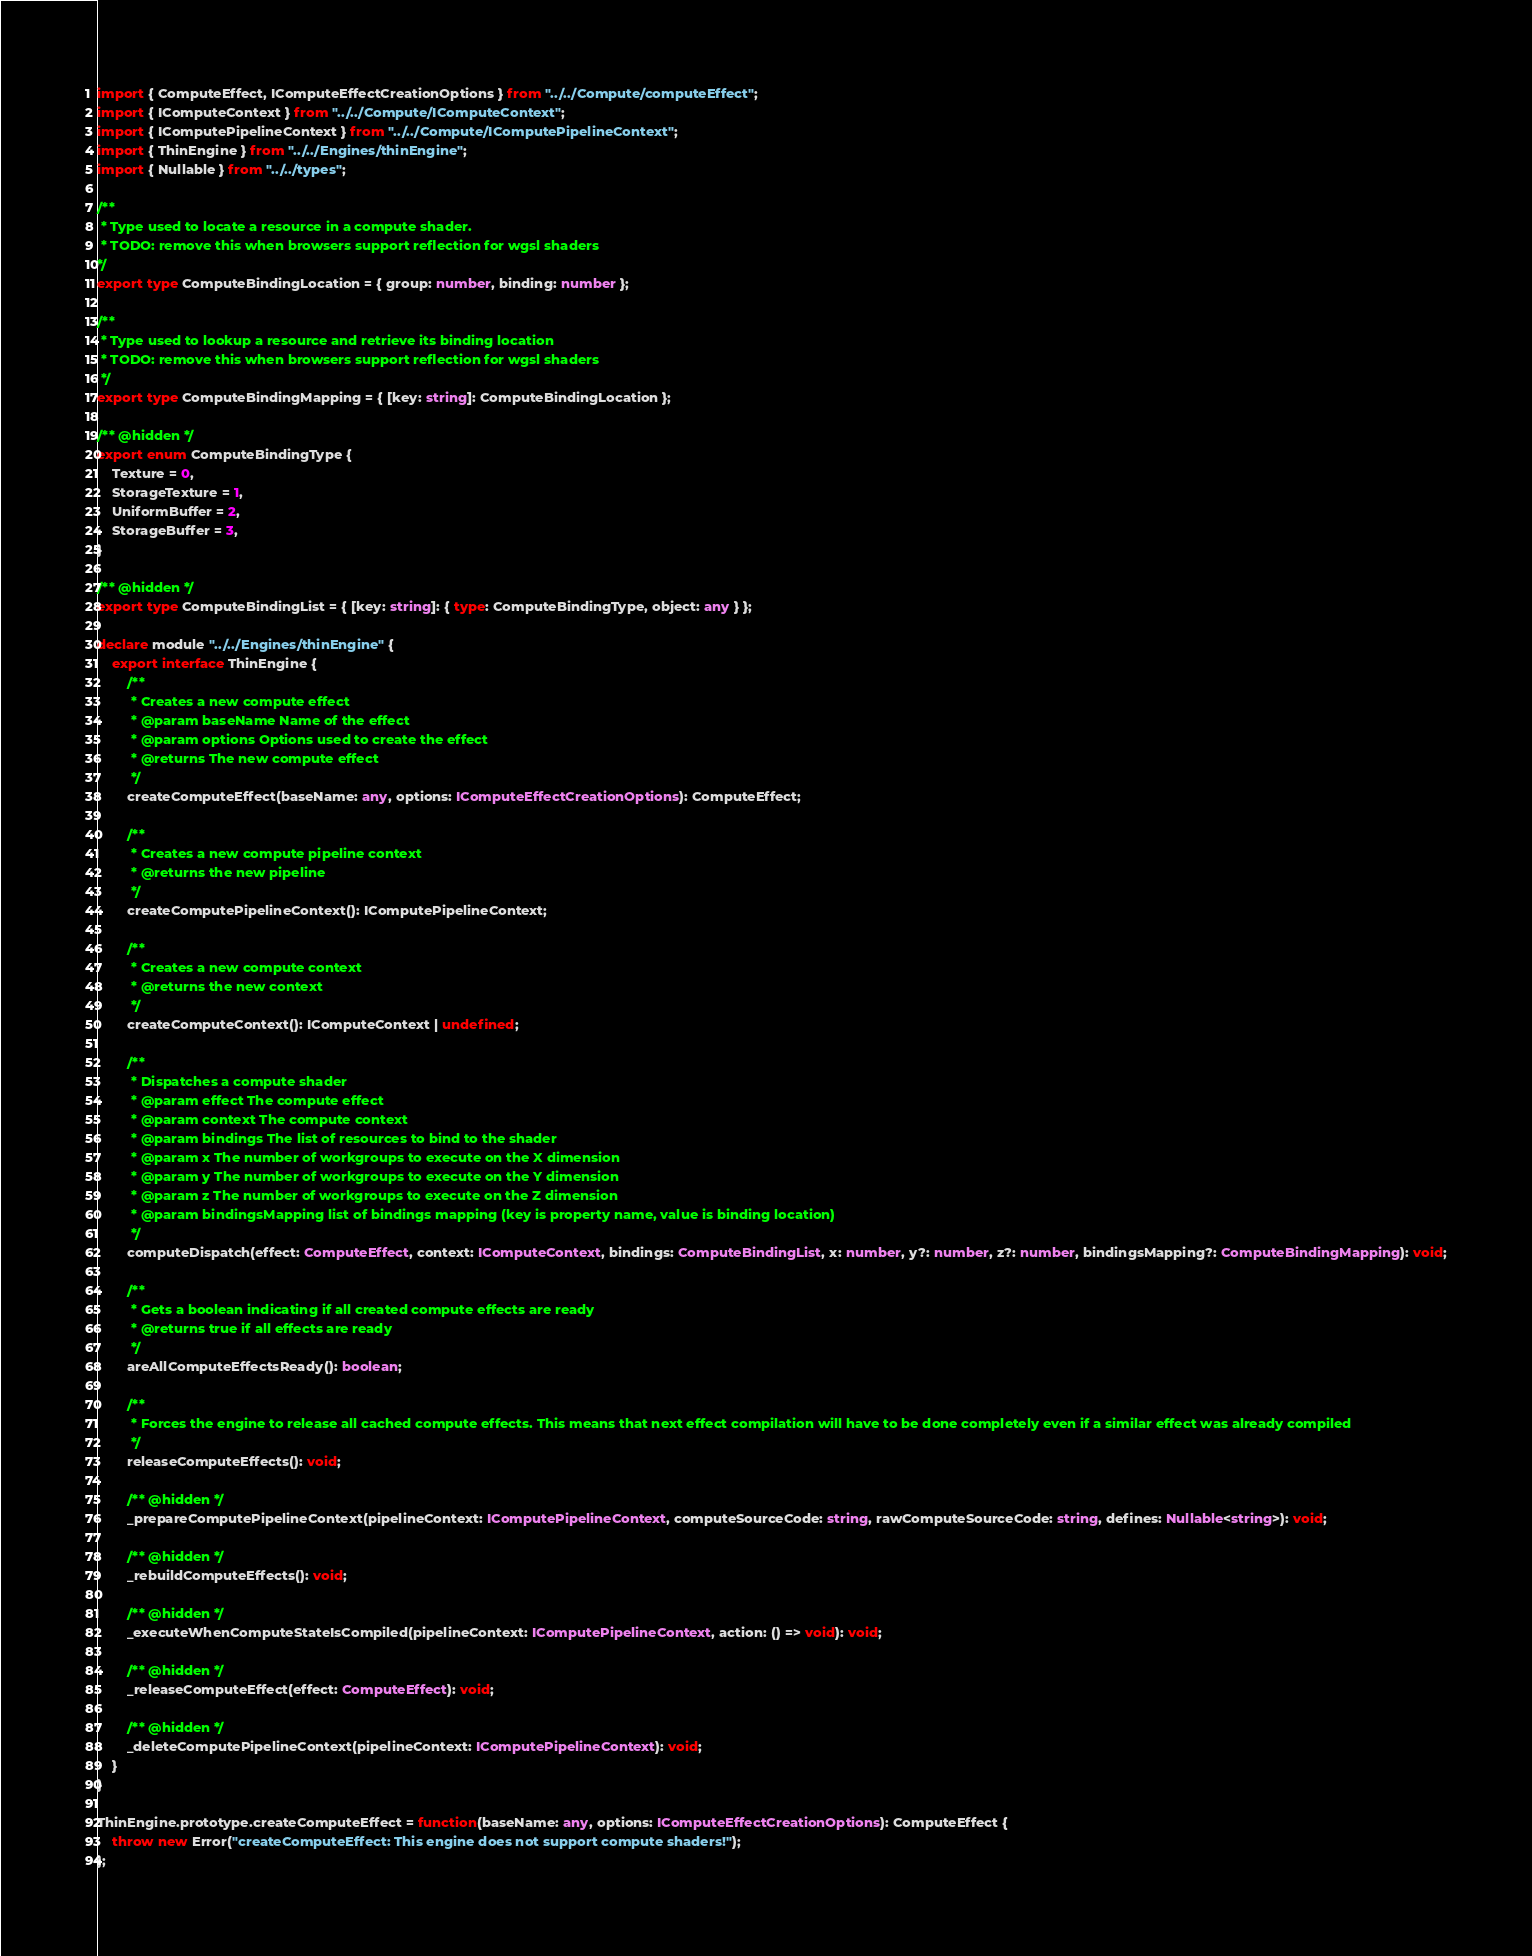Convert code to text. <code><loc_0><loc_0><loc_500><loc_500><_TypeScript_>import { ComputeEffect, IComputeEffectCreationOptions } from "../../Compute/computeEffect";
import { IComputeContext } from "../../Compute/IComputeContext";
import { IComputePipelineContext } from "../../Compute/IComputePipelineContext";
import { ThinEngine } from "../../Engines/thinEngine";
import { Nullable } from "../../types";

/**
 * Type used to locate a resource in a compute shader.
 * TODO: remove this when browsers support reflection for wgsl shaders
*/
export type ComputeBindingLocation = { group: number, binding: number };

/**
 * Type used to lookup a resource and retrieve its binding location
 * TODO: remove this when browsers support reflection for wgsl shaders
 */
export type ComputeBindingMapping = { [key: string]: ComputeBindingLocation };

/** @hidden */
export enum ComputeBindingType {
    Texture = 0,
    StorageTexture = 1,
    UniformBuffer = 2,
    StorageBuffer = 3,
}

/** @hidden */
export type ComputeBindingList = { [key: string]: { type: ComputeBindingType, object: any } };

declare module "../../Engines/thinEngine" {
    export interface ThinEngine {
        /**
         * Creates a new compute effect
         * @param baseName Name of the effect
         * @param options Options used to create the effect
         * @returns The new compute effect
         */
        createComputeEffect(baseName: any, options: IComputeEffectCreationOptions): ComputeEffect;

        /**
         * Creates a new compute pipeline context
         * @returns the new pipeline
         */
        createComputePipelineContext(): IComputePipelineContext;

        /**
         * Creates a new compute context
         * @returns the new context
         */
        createComputeContext(): IComputeContext | undefined;

        /**
         * Dispatches a compute shader
         * @param effect The compute effect
         * @param context The compute context
         * @param bindings The list of resources to bind to the shader
         * @param x The number of workgroups to execute on the X dimension
         * @param y The number of workgroups to execute on the Y dimension
         * @param z The number of workgroups to execute on the Z dimension
         * @param bindingsMapping list of bindings mapping (key is property name, value is binding location)
         */
        computeDispatch(effect: ComputeEffect, context: IComputeContext, bindings: ComputeBindingList, x: number, y?: number, z?: number, bindingsMapping?: ComputeBindingMapping): void;

        /**
         * Gets a boolean indicating if all created compute effects are ready
         * @returns true if all effects are ready
         */
        areAllComputeEffectsReady(): boolean;

        /**
         * Forces the engine to release all cached compute effects. This means that next effect compilation will have to be done completely even if a similar effect was already compiled
         */
        releaseComputeEffects(): void;

        /** @hidden */
        _prepareComputePipelineContext(pipelineContext: IComputePipelineContext, computeSourceCode: string, rawComputeSourceCode: string, defines: Nullable<string>): void;

        /** @hidden */
        _rebuildComputeEffects(): void;

        /** @hidden */
        _executeWhenComputeStateIsCompiled(pipelineContext: IComputePipelineContext, action: () => void): void;

        /** @hidden */
        _releaseComputeEffect(effect: ComputeEffect): void;

        /** @hidden */
        _deleteComputePipelineContext(pipelineContext: IComputePipelineContext): void;
    }
}

ThinEngine.prototype.createComputeEffect = function(baseName: any, options: IComputeEffectCreationOptions): ComputeEffect {
    throw new Error("createComputeEffect: This engine does not support compute shaders!");
};
</code> 